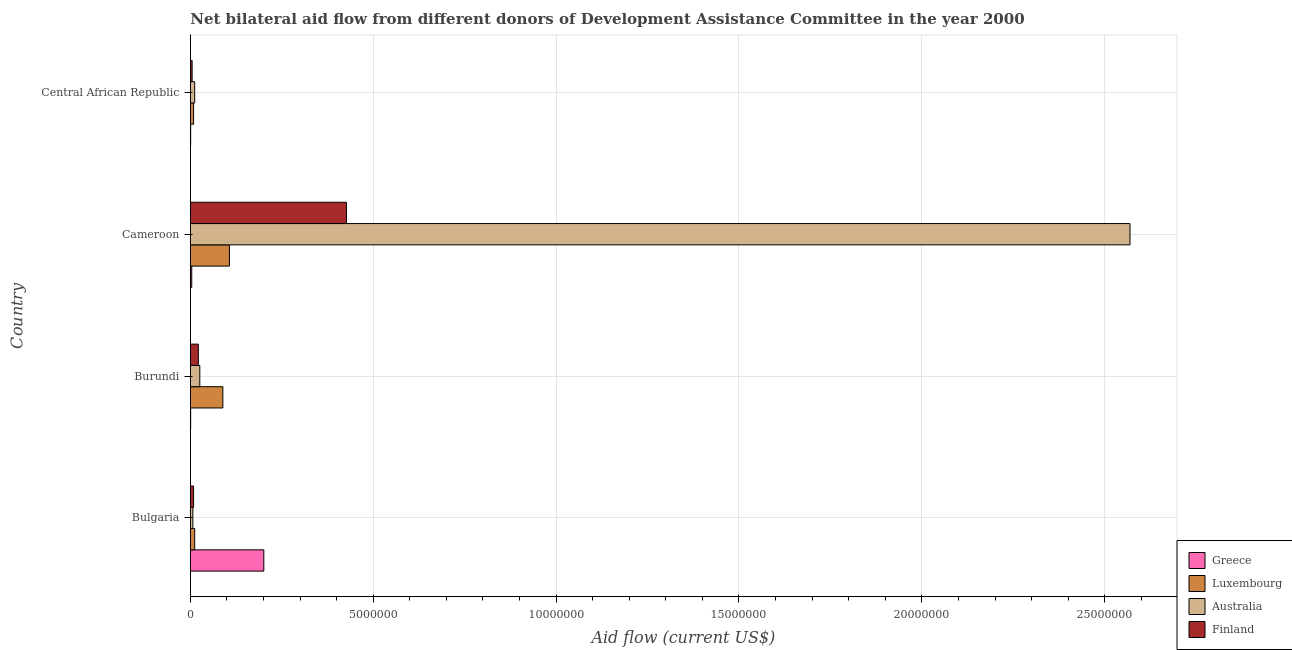Are the number of bars per tick equal to the number of legend labels?
Your answer should be very brief. Yes. What is the amount of aid given by australia in Bulgaria?
Your answer should be compact. 7.00e+04. Across all countries, what is the maximum amount of aid given by australia?
Provide a succinct answer. 2.57e+07. Across all countries, what is the minimum amount of aid given by finland?
Provide a short and direct response. 5.00e+04. In which country was the amount of aid given by finland maximum?
Offer a very short reply. Cameroon. In which country was the amount of aid given by finland minimum?
Keep it short and to the point. Central African Republic. What is the total amount of aid given by australia in the graph?
Your answer should be very brief. 2.61e+07. What is the difference between the amount of aid given by australia in Bulgaria and that in Cameroon?
Ensure brevity in your answer.  -2.56e+07. What is the difference between the amount of aid given by luxembourg in Burundi and the amount of aid given by finland in Bulgaria?
Offer a very short reply. 8.00e+05. What is the average amount of aid given by luxembourg per country?
Provide a short and direct response. 5.42e+05. What is the difference between the amount of aid given by australia and amount of aid given by luxembourg in Cameroon?
Provide a succinct answer. 2.46e+07. What is the ratio of the amount of aid given by australia in Bulgaria to that in Burundi?
Your answer should be very brief. 0.27. Is the amount of aid given by luxembourg in Bulgaria less than that in Burundi?
Your response must be concise. Yes. What is the difference between the highest and the second highest amount of aid given by greece?
Your answer should be compact. 1.97e+06. What is the difference between the highest and the lowest amount of aid given by australia?
Your answer should be very brief. 2.56e+07. Is it the case that in every country, the sum of the amount of aid given by greece and amount of aid given by australia is greater than the sum of amount of aid given by luxembourg and amount of aid given by finland?
Keep it short and to the point. No. What does the 3rd bar from the top in Burundi represents?
Offer a terse response. Luxembourg. What does the 4th bar from the bottom in Cameroon represents?
Your answer should be very brief. Finland. How many bars are there?
Make the answer very short. 16. How many countries are there in the graph?
Offer a very short reply. 4. What is the difference between two consecutive major ticks on the X-axis?
Give a very brief answer. 5.00e+06. Does the graph contain any zero values?
Give a very brief answer. No. Does the graph contain grids?
Your answer should be compact. Yes. How many legend labels are there?
Provide a short and direct response. 4. What is the title of the graph?
Provide a short and direct response. Net bilateral aid flow from different donors of Development Assistance Committee in the year 2000. What is the label or title of the X-axis?
Keep it short and to the point. Aid flow (current US$). What is the label or title of the Y-axis?
Keep it short and to the point. Country. What is the Aid flow (current US$) in Greece in Bulgaria?
Provide a short and direct response. 2.01e+06. What is the Aid flow (current US$) of Australia in Bulgaria?
Your answer should be very brief. 7.00e+04. What is the Aid flow (current US$) in Finland in Bulgaria?
Offer a very short reply. 9.00e+04. What is the Aid flow (current US$) in Luxembourg in Burundi?
Provide a short and direct response. 8.90e+05. What is the Aid flow (current US$) in Australia in Burundi?
Offer a terse response. 2.60e+05. What is the Aid flow (current US$) of Greece in Cameroon?
Provide a succinct answer. 4.00e+04. What is the Aid flow (current US$) of Luxembourg in Cameroon?
Provide a succinct answer. 1.07e+06. What is the Aid flow (current US$) of Australia in Cameroon?
Give a very brief answer. 2.57e+07. What is the Aid flow (current US$) of Finland in Cameroon?
Your answer should be very brief. 4.27e+06. What is the Aid flow (current US$) of Greece in Central African Republic?
Provide a succinct answer. 10000. What is the Aid flow (current US$) in Australia in Central African Republic?
Keep it short and to the point. 1.20e+05. What is the Aid flow (current US$) of Finland in Central African Republic?
Ensure brevity in your answer.  5.00e+04. Across all countries, what is the maximum Aid flow (current US$) in Greece?
Your answer should be very brief. 2.01e+06. Across all countries, what is the maximum Aid flow (current US$) of Luxembourg?
Make the answer very short. 1.07e+06. Across all countries, what is the maximum Aid flow (current US$) of Australia?
Your response must be concise. 2.57e+07. Across all countries, what is the maximum Aid flow (current US$) of Finland?
Offer a terse response. 4.27e+06. Across all countries, what is the minimum Aid flow (current US$) in Luxembourg?
Provide a short and direct response. 9.00e+04. Across all countries, what is the minimum Aid flow (current US$) of Finland?
Offer a terse response. 5.00e+04. What is the total Aid flow (current US$) of Greece in the graph?
Make the answer very short. 2.07e+06. What is the total Aid flow (current US$) of Luxembourg in the graph?
Keep it short and to the point. 2.17e+06. What is the total Aid flow (current US$) in Australia in the graph?
Give a very brief answer. 2.61e+07. What is the total Aid flow (current US$) in Finland in the graph?
Provide a short and direct response. 4.63e+06. What is the difference between the Aid flow (current US$) in Greece in Bulgaria and that in Burundi?
Your answer should be very brief. 2.00e+06. What is the difference between the Aid flow (current US$) of Luxembourg in Bulgaria and that in Burundi?
Your answer should be compact. -7.70e+05. What is the difference between the Aid flow (current US$) of Australia in Bulgaria and that in Burundi?
Keep it short and to the point. -1.90e+05. What is the difference between the Aid flow (current US$) in Greece in Bulgaria and that in Cameroon?
Your answer should be very brief. 1.97e+06. What is the difference between the Aid flow (current US$) in Luxembourg in Bulgaria and that in Cameroon?
Give a very brief answer. -9.50e+05. What is the difference between the Aid flow (current US$) in Australia in Bulgaria and that in Cameroon?
Your response must be concise. -2.56e+07. What is the difference between the Aid flow (current US$) of Finland in Bulgaria and that in Cameroon?
Make the answer very short. -4.18e+06. What is the difference between the Aid flow (current US$) of Greece in Bulgaria and that in Central African Republic?
Keep it short and to the point. 2.00e+06. What is the difference between the Aid flow (current US$) in Australia in Bulgaria and that in Central African Republic?
Your answer should be very brief. -5.00e+04. What is the difference between the Aid flow (current US$) of Finland in Bulgaria and that in Central African Republic?
Provide a short and direct response. 4.00e+04. What is the difference between the Aid flow (current US$) of Greece in Burundi and that in Cameroon?
Offer a very short reply. -3.00e+04. What is the difference between the Aid flow (current US$) in Luxembourg in Burundi and that in Cameroon?
Your response must be concise. -1.80e+05. What is the difference between the Aid flow (current US$) in Australia in Burundi and that in Cameroon?
Provide a short and direct response. -2.54e+07. What is the difference between the Aid flow (current US$) in Finland in Burundi and that in Cameroon?
Give a very brief answer. -4.05e+06. What is the difference between the Aid flow (current US$) of Greece in Cameroon and that in Central African Republic?
Your response must be concise. 3.00e+04. What is the difference between the Aid flow (current US$) in Luxembourg in Cameroon and that in Central African Republic?
Your answer should be compact. 9.80e+05. What is the difference between the Aid flow (current US$) in Australia in Cameroon and that in Central African Republic?
Give a very brief answer. 2.56e+07. What is the difference between the Aid flow (current US$) in Finland in Cameroon and that in Central African Republic?
Your answer should be compact. 4.22e+06. What is the difference between the Aid flow (current US$) in Greece in Bulgaria and the Aid flow (current US$) in Luxembourg in Burundi?
Ensure brevity in your answer.  1.12e+06. What is the difference between the Aid flow (current US$) in Greece in Bulgaria and the Aid flow (current US$) in Australia in Burundi?
Give a very brief answer. 1.75e+06. What is the difference between the Aid flow (current US$) of Greece in Bulgaria and the Aid flow (current US$) of Finland in Burundi?
Offer a very short reply. 1.79e+06. What is the difference between the Aid flow (current US$) of Luxembourg in Bulgaria and the Aid flow (current US$) of Finland in Burundi?
Your response must be concise. -1.00e+05. What is the difference between the Aid flow (current US$) in Greece in Bulgaria and the Aid flow (current US$) in Luxembourg in Cameroon?
Keep it short and to the point. 9.40e+05. What is the difference between the Aid flow (current US$) of Greece in Bulgaria and the Aid flow (current US$) of Australia in Cameroon?
Make the answer very short. -2.37e+07. What is the difference between the Aid flow (current US$) in Greece in Bulgaria and the Aid flow (current US$) in Finland in Cameroon?
Make the answer very short. -2.26e+06. What is the difference between the Aid flow (current US$) in Luxembourg in Bulgaria and the Aid flow (current US$) in Australia in Cameroon?
Give a very brief answer. -2.56e+07. What is the difference between the Aid flow (current US$) in Luxembourg in Bulgaria and the Aid flow (current US$) in Finland in Cameroon?
Your answer should be compact. -4.15e+06. What is the difference between the Aid flow (current US$) in Australia in Bulgaria and the Aid flow (current US$) in Finland in Cameroon?
Your answer should be very brief. -4.20e+06. What is the difference between the Aid flow (current US$) in Greece in Bulgaria and the Aid flow (current US$) in Luxembourg in Central African Republic?
Provide a short and direct response. 1.92e+06. What is the difference between the Aid flow (current US$) in Greece in Bulgaria and the Aid flow (current US$) in Australia in Central African Republic?
Provide a short and direct response. 1.89e+06. What is the difference between the Aid flow (current US$) in Greece in Bulgaria and the Aid flow (current US$) in Finland in Central African Republic?
Provide a succinct answer. 1.96e+06. What is the difference between the Aid flow (current US$) of Luxembourg in Bulgaria and the Aid flow (current US$) of Australia in Central African Republic?
Offer a very short reply. 0. What is the difference between the Aid flow (current US$) of Australia in Bulgaria and the Aid flow (current US$) of Finland in Central African Republic?
Provide a short and direct response. 2.00e+04. What is the difference between the Aid flow (current US$) of Greece in Burundi and the Aid flow (current US$) of Luxembourg in Cameroon?
Make the answer very short. -1.06e+06. What is the difference between the Aid flow (current US$) of Greece in Burundi and the Aid flow (current US$) of Australia in Cameroon?
Provide a short and direct response. -2.57e+07. What is the difference between the Aid flow (current US$) in Greece in Burundi and the Aid flow (current US$) in Finland in Cameroon?
Make the answer very short. -4.26e+06. What is the difference between the Aid flow (current US$) of Luxembourg in Burundi and the Aid flow (current US$) of Australia in Cameroon?
Offer a terse response. -2.48e+07. What is the difference between the Aid flow (current US$) of Luxembourg in Burundi and the Aid flow (current US$) of Finland in Cameroon?
Give a very brief answer. -3.38e+06. What is the difference between the Aid flow (current US$) of Australia in Burundi and the Aid flow (current US$) of Finland in Cameroon?
Provide a short and direct response. -4.01e+06. What is the difference between the Aid flow (current US$) in Greece in Burundi and the Aid flow (current US$) in Finland in Central African Republic?
Offer a very short reply. -4.00e+04. What is the difference between the Aid flow (current US$) in Luxembourg in Burundi and the Aid flow (current US$) in Australia in Central African Republic?
Provide a short and direct response. 7.70e+05. What is the difference between the Aid flow (current US$) in Luxembourg in Burundi and the Aid flow (current US$) in Finland in Central African Republic?
Provide a short and direct response. 8.40e+05. What is the difference between the Aid flow (current US$) in Australia in Burundi and the Aid flow (current US$) in Finland in Central African Republic?
Your answer should be compact. 2.10e+05. What is the difference between the Aid flow (current US$) of Greece in Cameroon and the Aid flow (current US$) of Luxembourg in Central African Republic?
Your answer should be compact. -5.00e+04. What is the difference between the Aid flow (current US$) of Luxembourg in Cameroon and the Aid flow (current US$) of Australia in Central African Republic?
Offer a terse response. 9.50e+05. What is the difference between the Aid flow (current US$) in Luxembourg in Cameroon and the Aid flow (current US$) in Finland in Central African Republic?
Ensure brevity in your answer.  1.02e+06. What is the difference between the Aid flow (current US$) of Australia in Cameroon and the Aid flow (current US$) of Finland in Central African Republic?
Make the answer very short. 2.56e+07. What is the average Aid flow (current US$) of Greece per country?
Give a very brief answer. 5.18e+05. What is the average Aid flow (current US$) of Luxembourg per country?
Provide a short and direct response. 5.42e+05. What is the average Aid flow (current US$) of Australia per country?
Offer a terse response. 6.54e+06. What is the average Aid flow (current US$) in Finland per country?
Your answer should be very brief. 1.16e+06. What is the difference between the Aid flow (current US$) in Greece and Aid flow (current US$) in Luxembourg in Bulgaria?
Offer a very short reply. 1.89e+06. What is the difference between the Aid flow (current US$) in Greece and Aid flow (current US$) in Australia in Bulgaria?
Offer a very short reply. 1.94e+06. What is the difference between the Aid flow (current US$) of Greece and Aid flow (current US$) of Finland in Bulgaria?
Offer a terse response. 1.92e+06. What is the difference between the Aid flow (current US$) of Luxembourg and Aid flow (current US$) of Finland in Bulgaria?
Make the answer very short. 3.00e+04. What is the difference between the Aid flow (current US$) in Australia and Aid flow (current US$) in Finland in Bulgaria?
Your answer should be very brief. -2.00e+04. What is the difference between the Aid flow (current US$) of Greece and Aid flow (current US$) of Luxembourg in Burundi?
Provide a succinct answer. -8.80e+05. What is the difference between the Aid flow (current US$) in Greece and Aid flow (current US$) in Finland in Burundi?
Make the answer very short. -2.10e+05. What is the difference between the Aid flow (current US$) of Luxembourg and Aid flow (current US$) of Australia in Burundi?
Ensure brevity in your answer.  6.30e+05. What is the difference between the Aid flow (current US$) in Luxembourg and Aid flow (current US$) in Finland in Burundi?
Offer a terse response. 6.70e+05. What is the difference between the Aid flow (current US$) of Australia and Aid flow (current US$) of Finland in Burundi?
Offer a terse response. 4.00e+04. What is the difference between the Aid flow (current US$) in Greece and Aid flow (current US$) in Luxembourg in Cameroon?
Offer a very short reply. -1.03e+06. What is the difference between the Aid flow (current US$) in Greece and Aid flow (current US$) in Australia in Cameroon?
Ensure brevity in your answer.  -2.56e+07. What is the difference between the Aid flow (current US$) of Greece and Aid flow (current US$) of Finland in Cameroon?
Your answer should be compact. -4.23e+06. What is the difference between the Aid flow (current US$) in Luxembourg and Aid flow (current US$) in Australia in Cameroon?
Make the answer very short. -2.46e+07. What is the difference between the Aid flow (current US$) of Luxembourg and Aid flow (current US$) of Finland in Cameroon?
Give a very brief answer. -3.20e+06. What is the difference between the Aid flow (current US$) of Australia and Aid flow (current US$) of Finland in Cameroon?
Offer a terse response. 2.14e+07. What is the difference between the Aid flow (current US$) of Greece and Aid flow (current US$) of Finland in Central African Republic?
Keep it short and to the point. -4.00e+04. What is the difference between the Aid flow (current US$) of Luxembourg and Aid flow (current US$) of Finland in Central African Republic?
Keep it short and to the point. 4.00e+04. What is the ratio of the Aid flow (current US$) in Greece in Bulgaria to that in Burundi?
Provide a succinct answer. 201. What is the ratio of the Aid flow (current US$) of Luxembourg in Bulgaria to that in Burundi?
Keep it short and to the point. 0.13. What is the ratio of the Aid flow (current US$) of Australia in Bulgaria to that in Burundi?
Make the answer very short. 0.27. What is the ratio of the Aid flow (current US$) of Finland in Bulgaria to that in Burundi?
Keep it short and to the point. 0.41. What is the ratio of the Aid flow (current US$) in Greece in Bulgaria to that in Cameroon?
Give a very brief answer. 50.25. What is the ratio of the Aid flow (current US$) in Luxembourg in Bulgaria to that in Cameroon?
Your answer should be compact. 0.11. What is the ratio of the Aid flow (current US$) of Australia in Bulgaria to that in Cameroon?
Give a very brief answer. 0. What is the ratio of the Aid flow (current US$) of Finland in Bulgaria to that in Cameroon?
Make the answer very short. 0.02. What is the ratio of the Aid flow (current US$) of Greece in Bulgaria to that in Central African Republic?
Your answer should be compact. 201. What is the ratio of the Aid flow (current US$) of Luxembourg in Bulgaria to that in Central African Republic?
Keep it short and to the point. 1.33. What is the ratio of the Aid flow (current US$) in Australia in Bulgaria to that in Central African Republic?
Your response must be concise. 0.58. What is the ratio of the Aid flow (current US$) in Luxembourg in Burundi to that in Cameroon?
Keep it short and to the point. 0.83. What is the ratio of the Aid flow (current US$) of Australia in Burundi to that in Cameroon?
Offer a very short reply. 0.01. What is the ratio of the Aid flow (current US$) of Finland in Burundi to that in Cameroon?
Give a very brief answer. 0.05. What is the ratio of the Aid flow (current US$) of Greece in Burundi to that in Central African Republic?
Your response must be concise. 1. What is the ratio of the Aid flow (current US$) in Luxembourg in Burundi to that in Central African Republic?
Offer a terse response. 9.89. What is the ratio of the Aid flow (current US$) of Australia in Burundi to that in Central African Republic?
Ensure brevity in your answer.  2.17. What is the ratio of the Aid flow (current US$) of Luxembourg in Cameroon to that in Central African Republic?
Make the answer very short. 11.89. What is the ratio of the Aid flow (current US$) of Australia in Cameroon to that in Central African Republic?
Your response must be concise. 214.08. What is the ratio of the Aid flow (current US$) of Finland in Cameroon to that in Central African Republic?
Ensure brevity in your answer.  85.4. What is the difference between the highest and the second highest Aid flow (current US$) in Greece?
Offer a terse response. 1.97e+06. What is the difference between the highest and the second highest Aid flow (current US$) of Australia?
Make the answer very short. 2.54e+07. What is the difference between the highest and the second highest Aid flow (current US$) in Finland?
Provide a succinct answer. 4.05e+06. What is the difference between the highest and the lowest Aid flow (current US$) in Luxembourg?
Provide a succinct answer. 9.80e+05. What is the difference between the highest and the lowest Aid flow (current US$) of Australia?
Offer a terse response. 2.56e+07. What is the difference between the highest and the lowest Aid flow (current US$) of Finland?
Provide a short and direct response. 4.22e+06. 